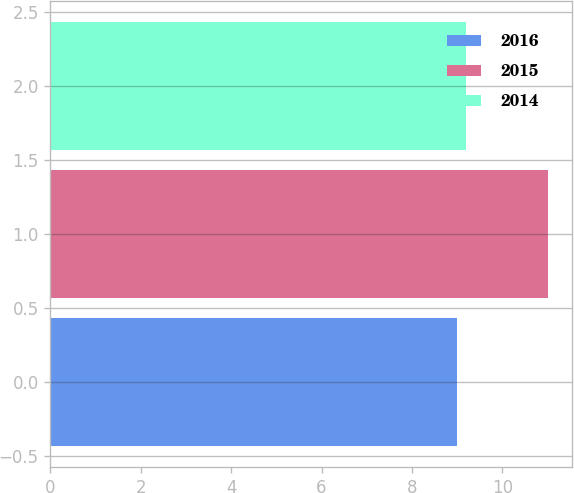<chart> <loc_0><loc_0><loc_500><loc_500><bar_chart><fcel>2016<fcel>2015<fcel>2014<nl><fcel>9<fcel>11<fcel>9.2<nl></chart> 